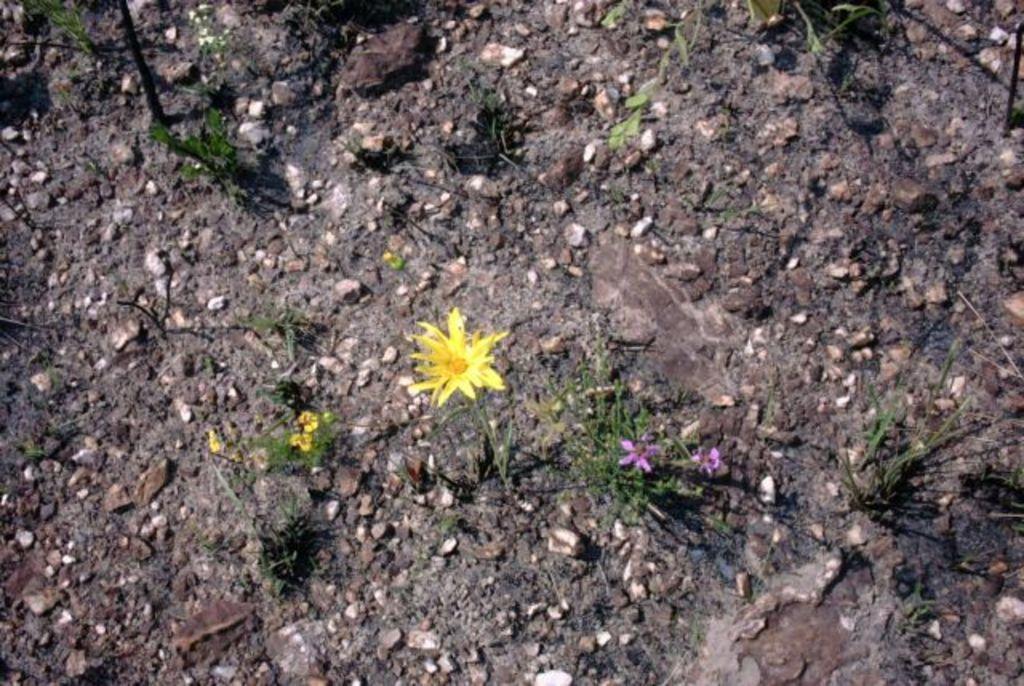Could you give a brief overview of what you see in this image? In this image, I can see the plants, stones and rocks on the ground. 